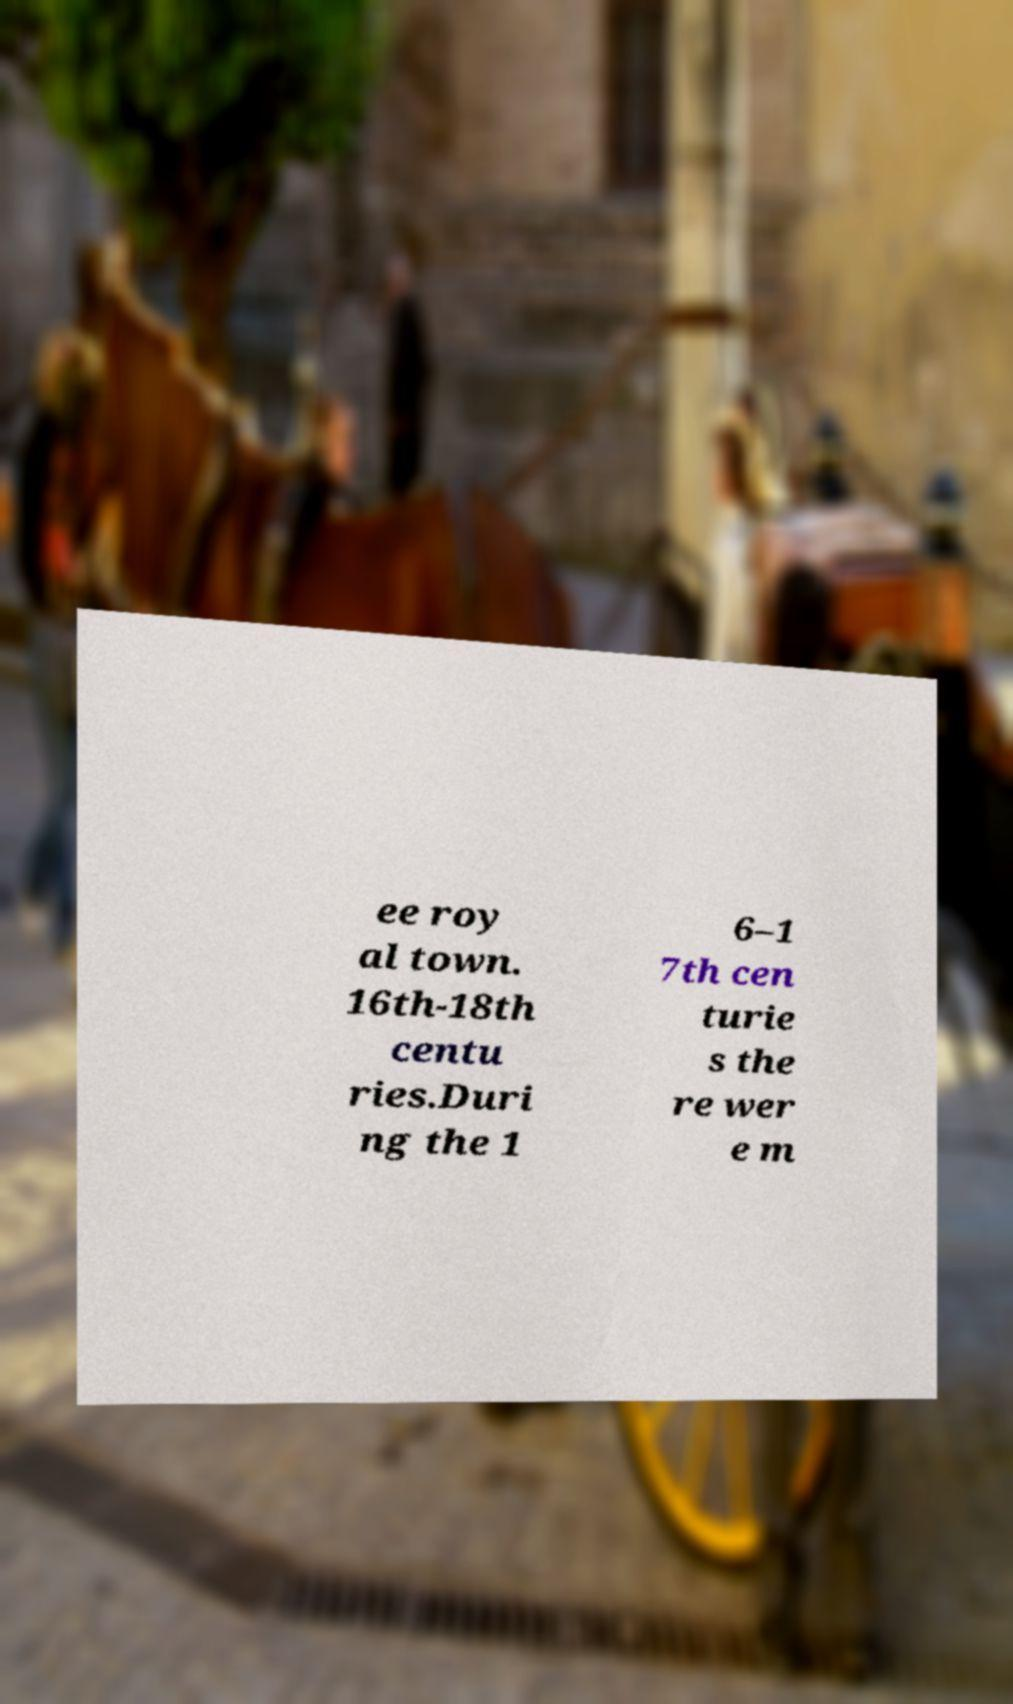For documentation purposes, I need the text within this image transcribed. Could you provide that? ee roy al town. 16th-18th centu ries.Duri ng the 1 6–1 7th cen turie s the re wer e m 